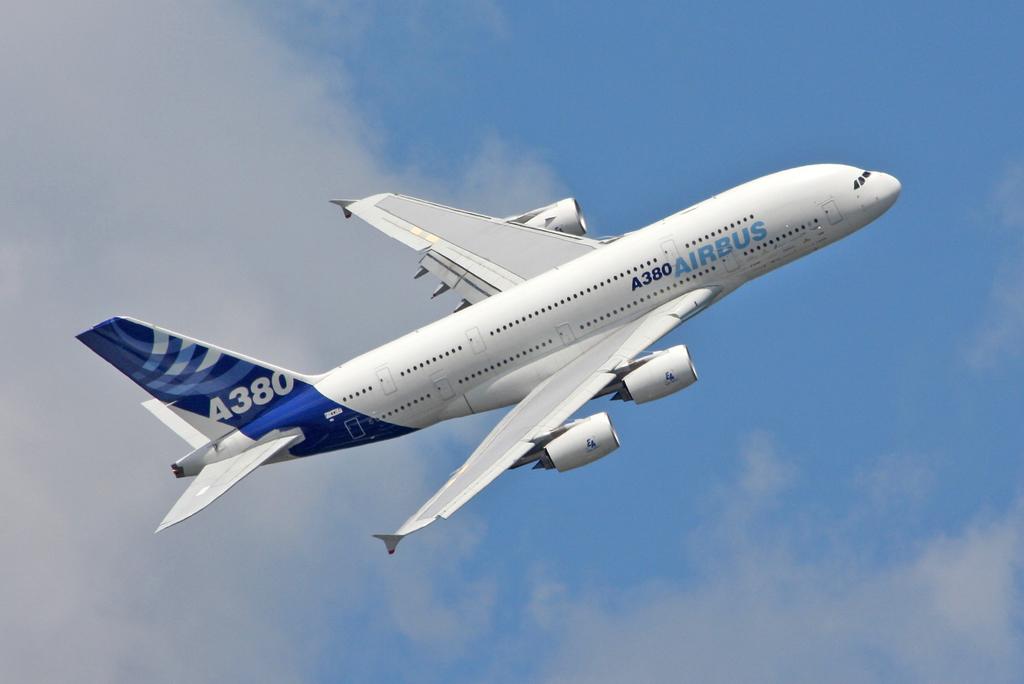What is the code on the tail of the plane?
Your response must be concise. A380. 